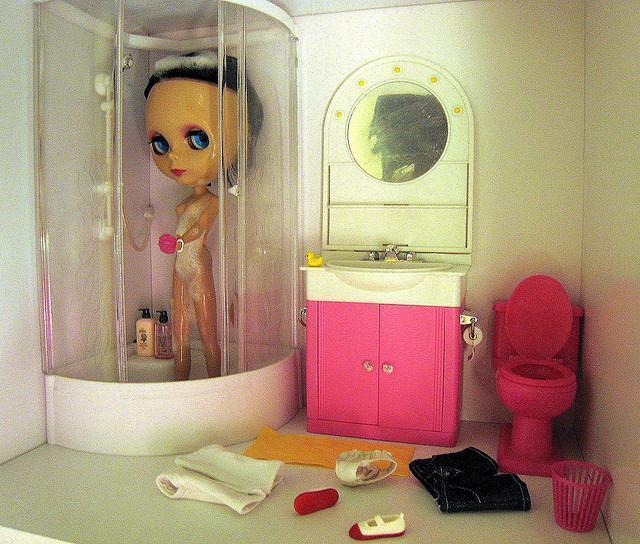How many umbrellas do you see?
Give a very brief answer. 0. 